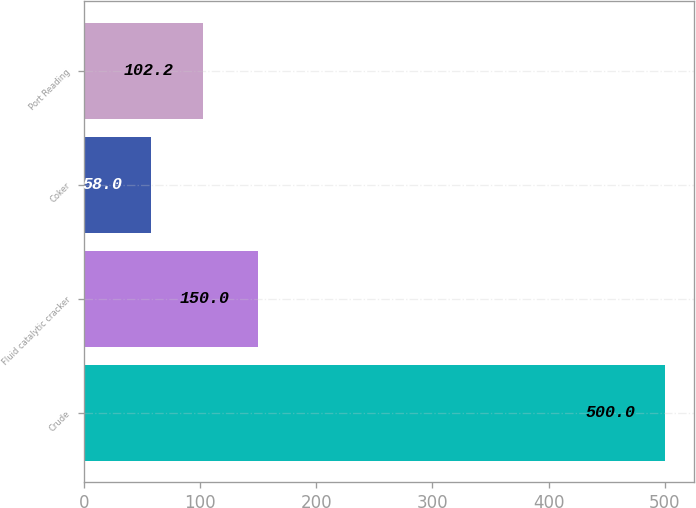<chart> <loc_0><loc_0><loc_500><loc_500><bar_chart><fcel>Crude<fcel>Fluid catalytic cracker<fcel>Coker<fcel>Port Reading<nl><fcel>500<fcel>150<fcel>58<fcel>102.2<nl></chart> 